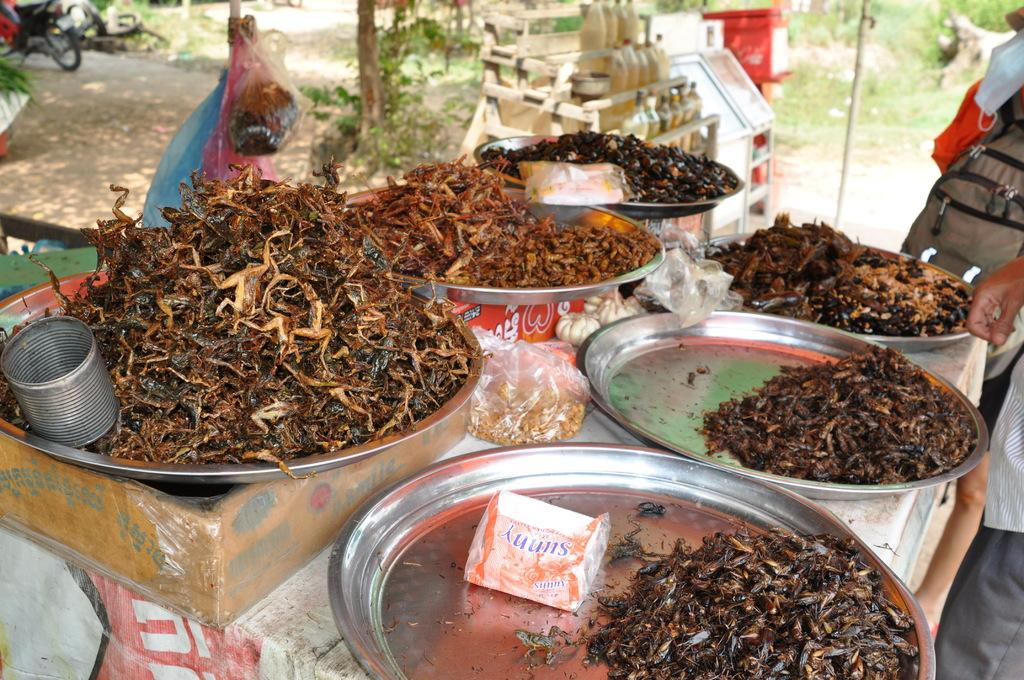What is the main piece of furniture in the image? There is a table in the image. What is placed on the table? There are plates on the table. What can be found inside the plates? There are food items in the plates. What can be seen in the background of the image? There are people standing and plants in the background of the image. What type of waste is being produced by the plants in the image? There is no waste being produced by the plants in the image; they are simply standing in the background. 